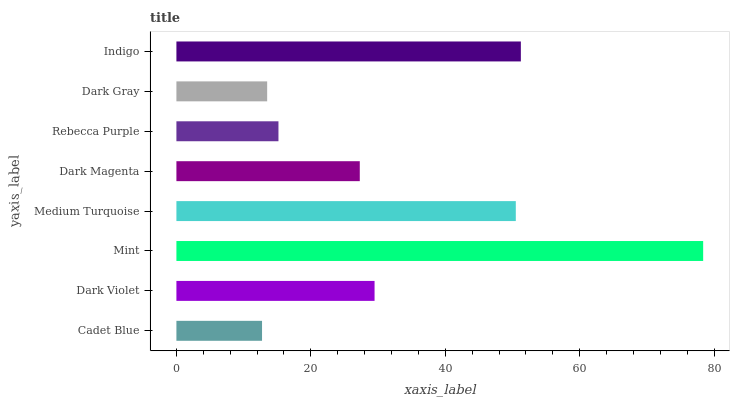Is Cadet Blue the minimum?
Answer yes or no. Yes. Is Mint the maximum?
Answer yes or no. Yes. Is Dark Violet the minimum?
Answer yes or no. No. Is Dark Violet the maximum?
Answer yes or no. No. Is Dark Violet greater than Cadet Blue?
Answer yes or no. Yes. Is Cadet Blue less than Dark Violet?
Answer yes or no. Yes. Is Cadet Blue greater than Dark Violet?
Answer yes or no. No. Is Dark Violet less than Cadet Blue?
Answer yes or no. No. Is Dark Violet the high median?
Answer yes or no. Yes. Is Dark Magenta the low median?
Answer yes or no. Yes. Is Medium Turquoise the high median?
Answer yes or no. No. Is Rebecca Purple the low median?
Answer yes or no. No. 